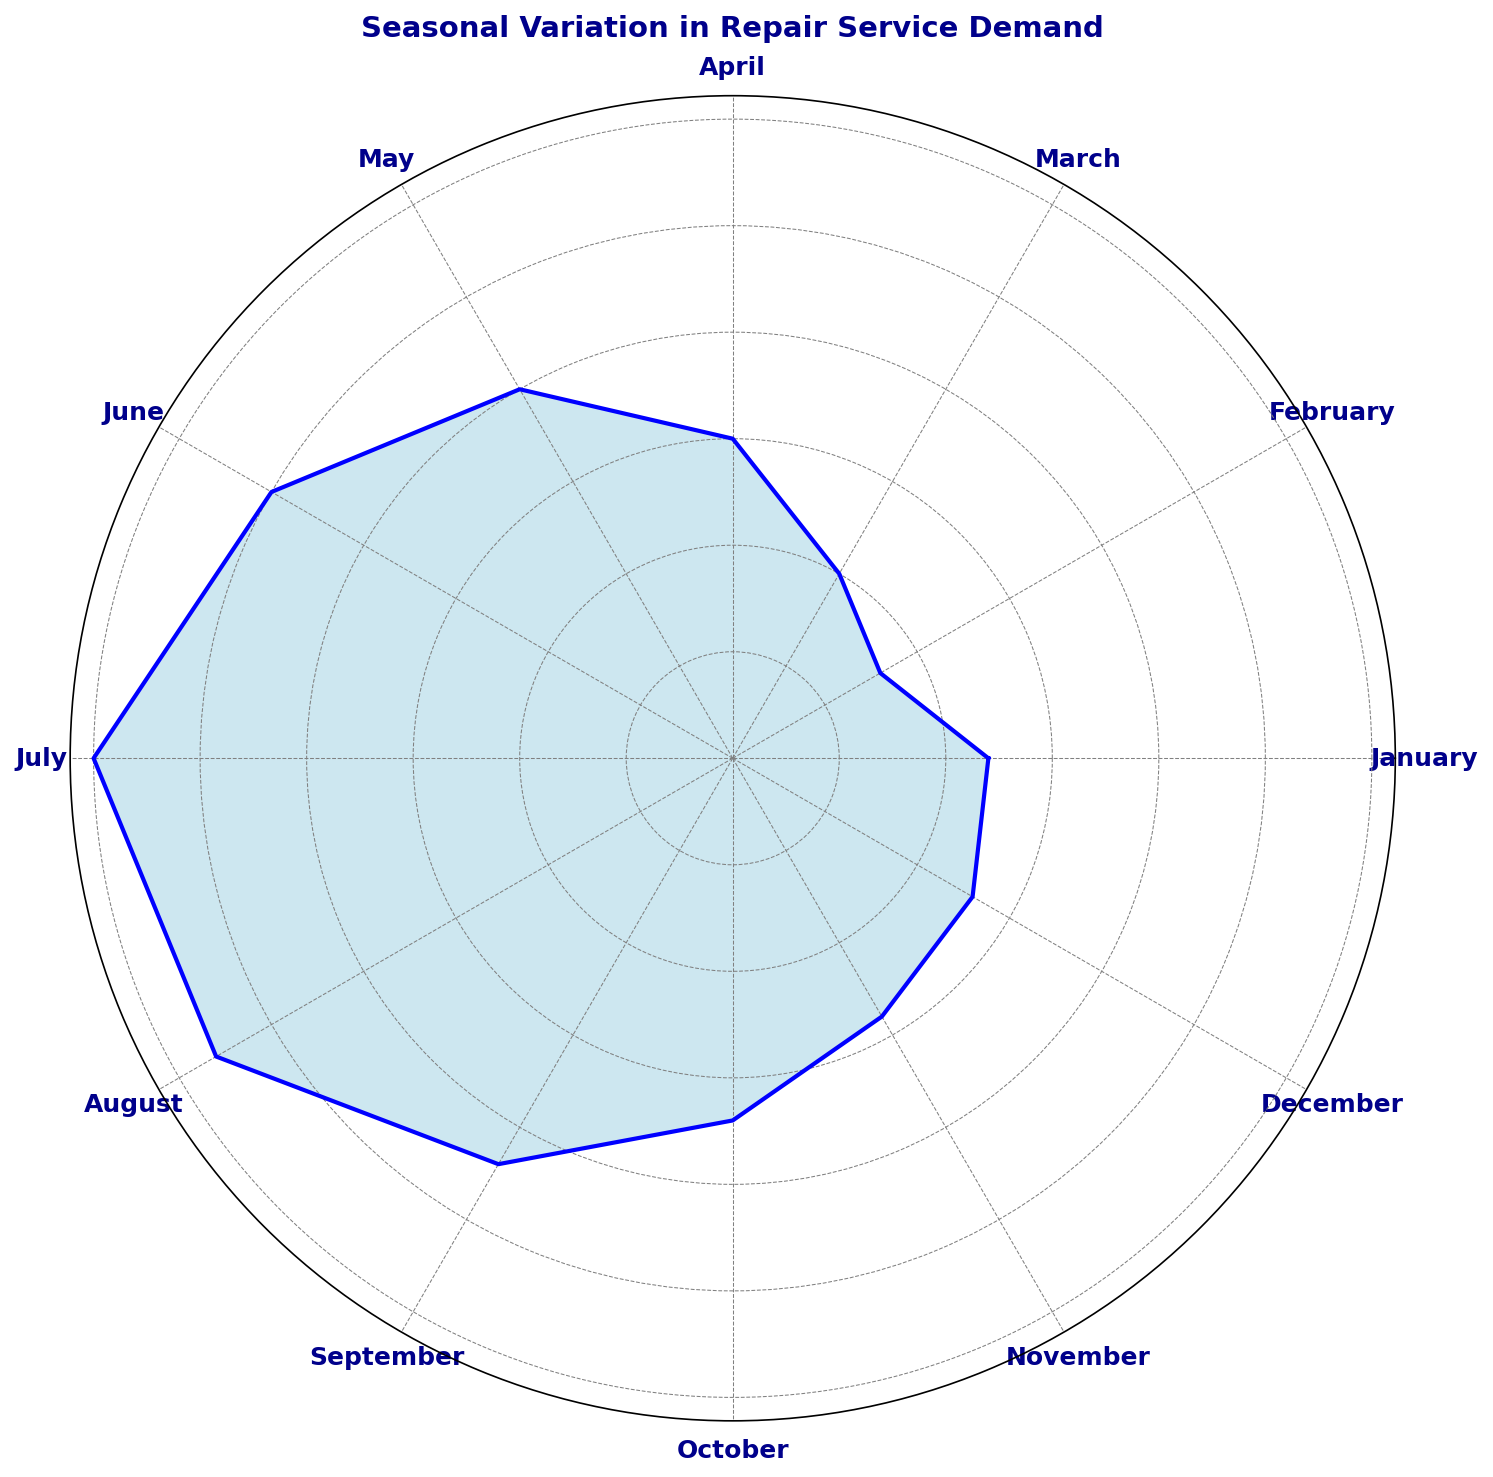What month has the highest repair service demand? Looking at the plot, July has the longest portion of the chart filled, indicating the highest demand.
Answer: July Which months have less demand than August? By comparing the length of the sections for each month, we can see that January, February, March, April, May, June, and December all have shorter lengths than August.
Answer: January, February, March, April, May, June, December What is the difference in repair service demand between July and February? July's demand is 300, and February's demand is 80. The difference is calculated as 300 - 80 = 220.
Answer: 220 What is the average repair service demand for the first quarter (January, February, March)? Add the demands for January (120), February (80), and March (100) and then divide by 3. (120 + 80 + 100) / 3 = 100.
Answer: 100 How does the demand in October compare to that in March? October's demand is 170, whereas March's demand is 100. Therefore, October's demand is higher.
Answer: October has higher demand What season has the lowest average repair service demand? (Winter: Dec-Feb, Spring: Mar-May, Summer: Jun-Aug, Fall: Sep-Nov) Calculate the average demand for each season: Winter (Dec-Feb): (130+120+80) / 3 = 110, Spring (Mar-May): (100+150+200) / 3 ≈ 150, Summer (Jun-Aug): (250+300+280) / 3 ≈ 276.67, Fall (Sep-Nov): (220+170+140) / 3 ≈ 176.67. Winter has the lowest average.
Answer: Winter Which month shows a notable increase in demand from the previous month? Identify months where the plot line shows a sharp rise. The most substantial increase is from February (80) to March (100), indicating a notable increase.
Answer: March Which months have a repair service demand higher than the annual average? First, calculate the annual average demand: (120+80+100+150+200+250+300+280+220+170+140+130) / 12 = 178.33. The months with demand higher than this average are May, June, July, August, and September.
Answer: May, June, July, August, September 